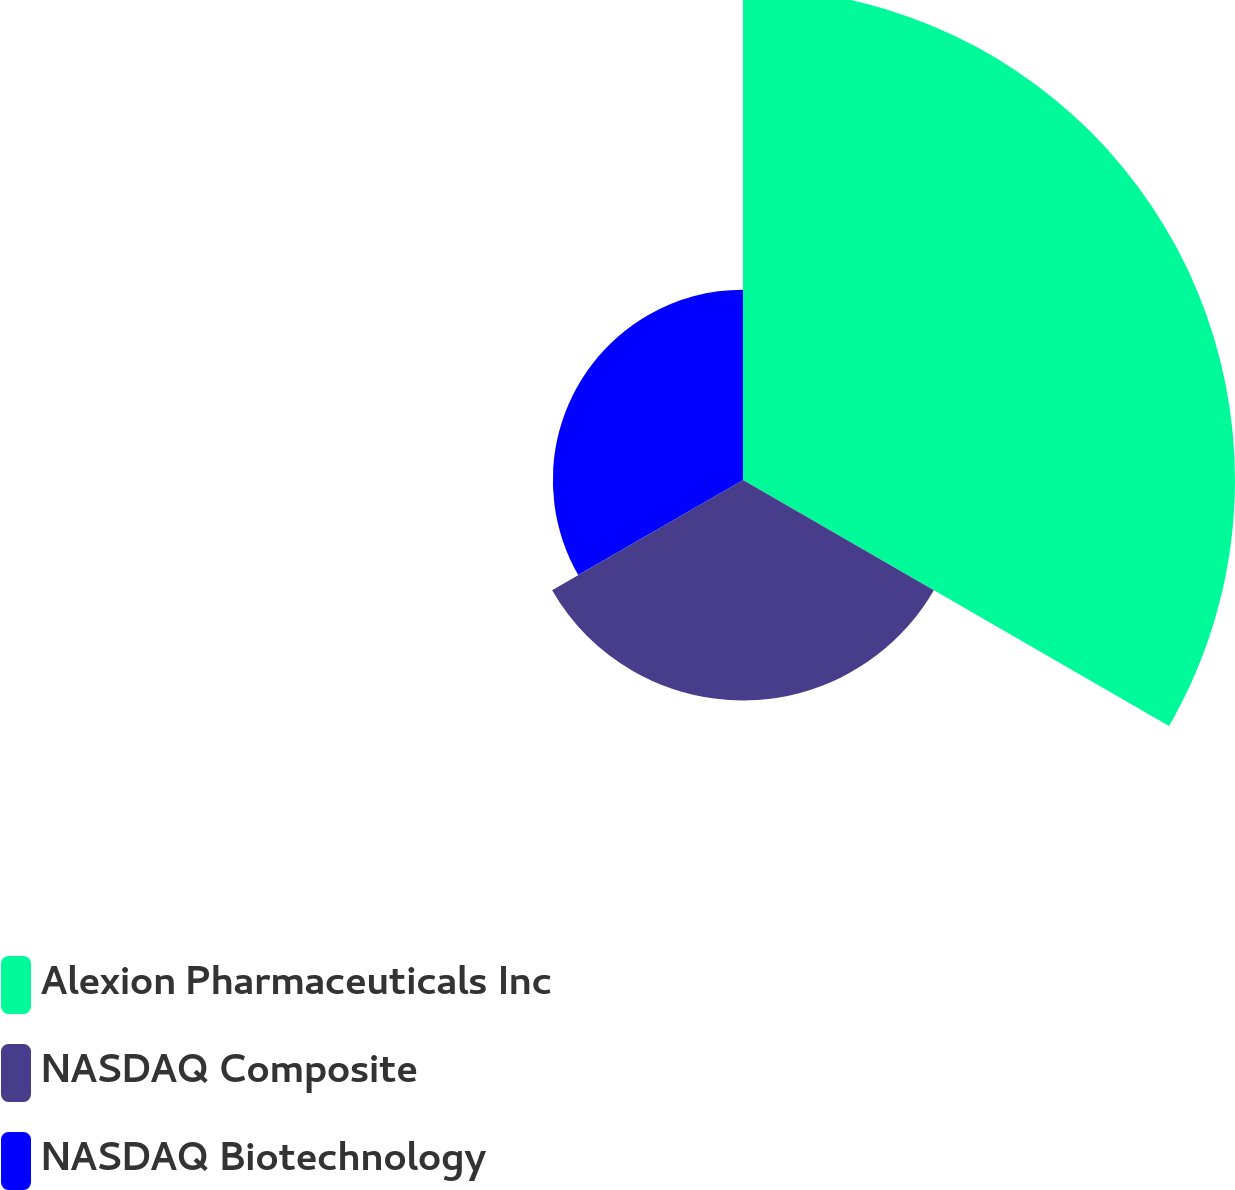Convert chart to OTSL. <chart><loc_0><loc_0><loc_500><loc_500><pie_chart><fcel>Alexion Pharmaceuticals Inc<fcel>NASDAQ Composite<fcel>NASDAQ Biotechnology<nl><fcel>54.51%<fcel>24.42%<fcel>21.07%<nl></chart> 